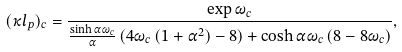Convert formula to latex. <formula><loc_0><loc_0><loc_500><loc_500>( \kappa l _ { p } ) _ { c } = \frac { \exp \omega _ { c } } { \frac { \sinh \alpha \omega _ { c } } { \alpha } \left ( 4 \omega _ { c } \left ( 1 + \alpha ^ { 2 } \right ) - 8 \right ) + \cosh \alpha \omega _ { c } \left ( 8 - 8 \omega _ { c } \right ) } ,</formula> 